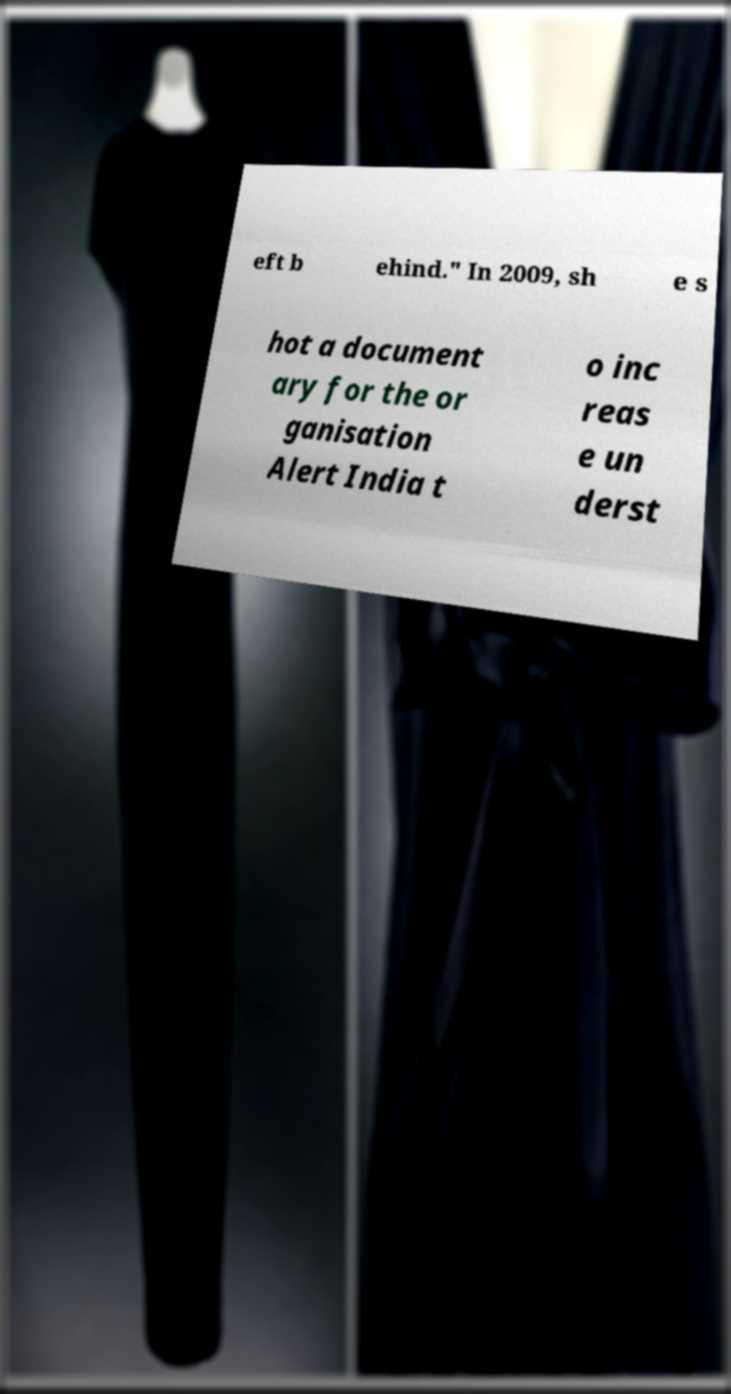Could you extract and type out the text from this image? eft b ehind." In 2009, sh e s hot a document ary for the or ganisation Alert India t o inc reas e un derst 